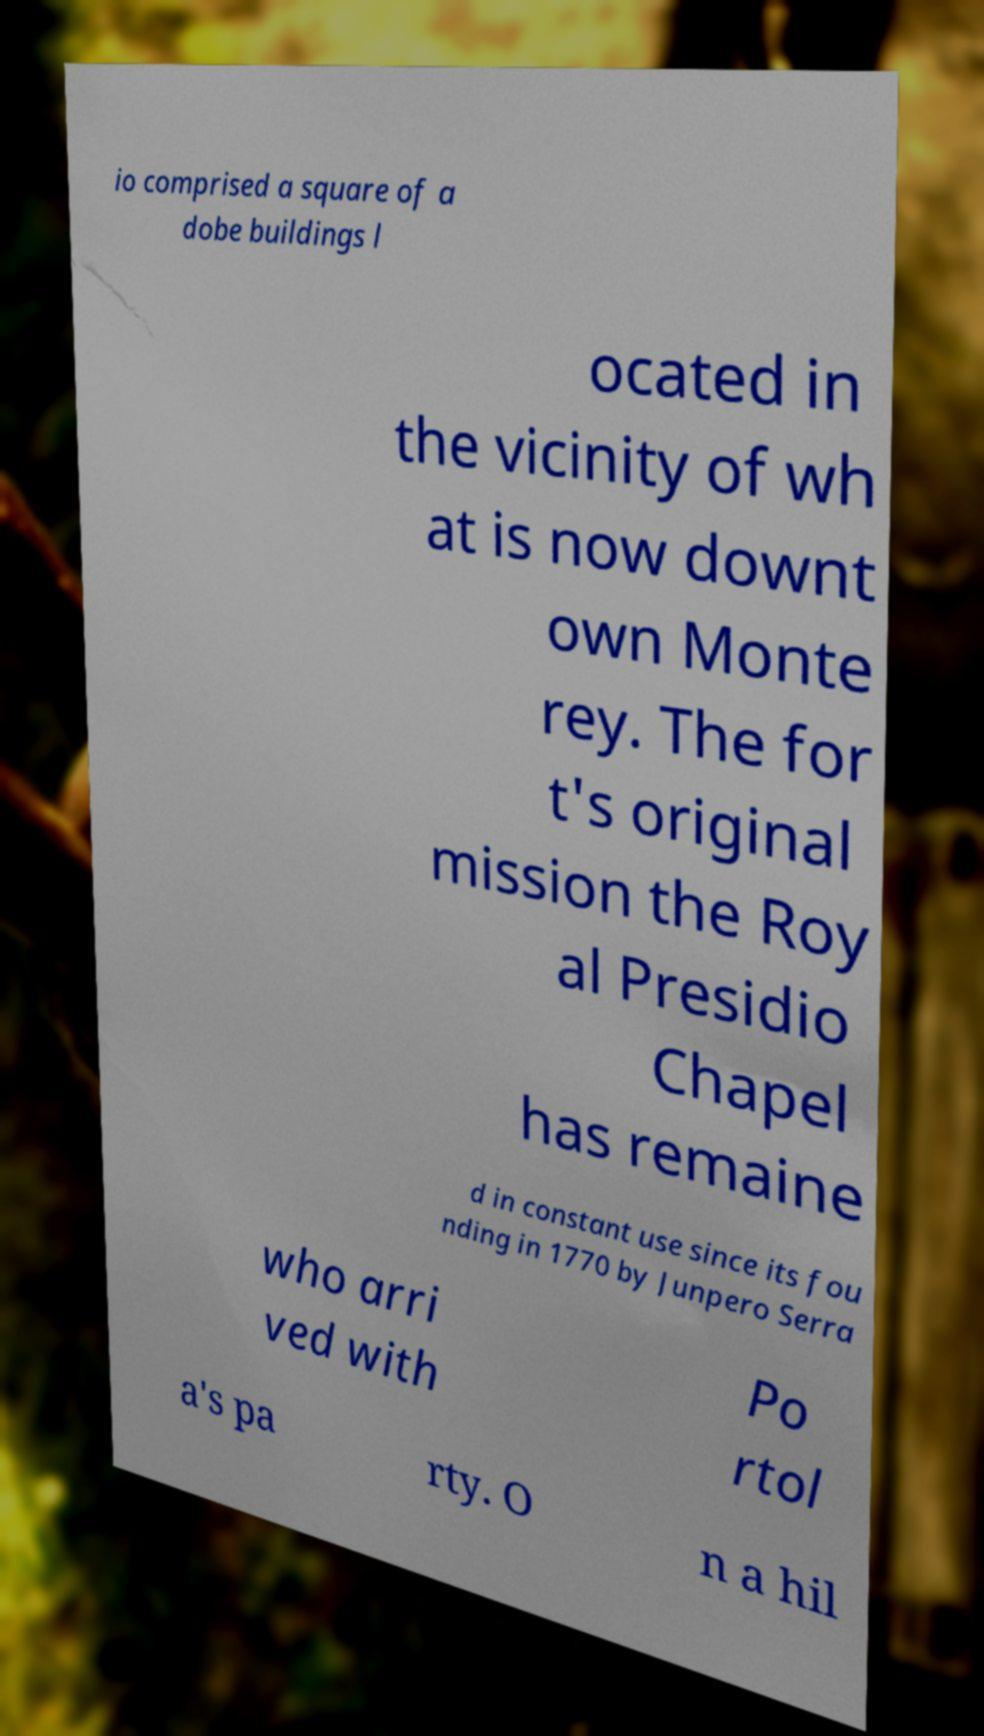I need the written content from this picture converted into text. Can you do that? io comprised a square of a dobe buildings l ocated in the vicinity of wh at is now downt own Monte rey. The for t's original mission the Roy al Presidio Chapel has remaine d in constant use since its fou nding in 1770 by Junpero Serra who arri ved with Po rtol a's pa rty. O n a hil 